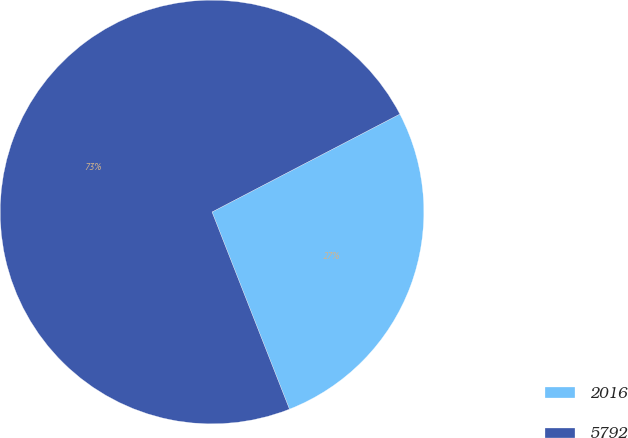Convert chart to OTSL. <chart><loc_0><loc_0><loc_500><loc_500><pie_chart><fcel>2016<fcel>5792<nl><fcel>26.69%<fcel>73.31%<nl></chart> 